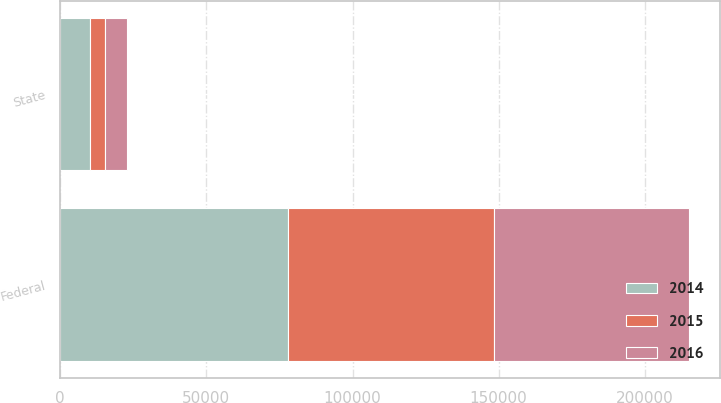Convert chart. <chart><loc_0><loc_0><loc_500><loc_500><stacked_bar_chart><ecel><fcel>Federal<fcel>State<nl><fcel>2016<fcel>66574<fcel>7571<nl><fcel>2015<fcel>70555<fcel>5221<nl><fcel>2014<fcel>77937<fcel>10166<nl></chart> 